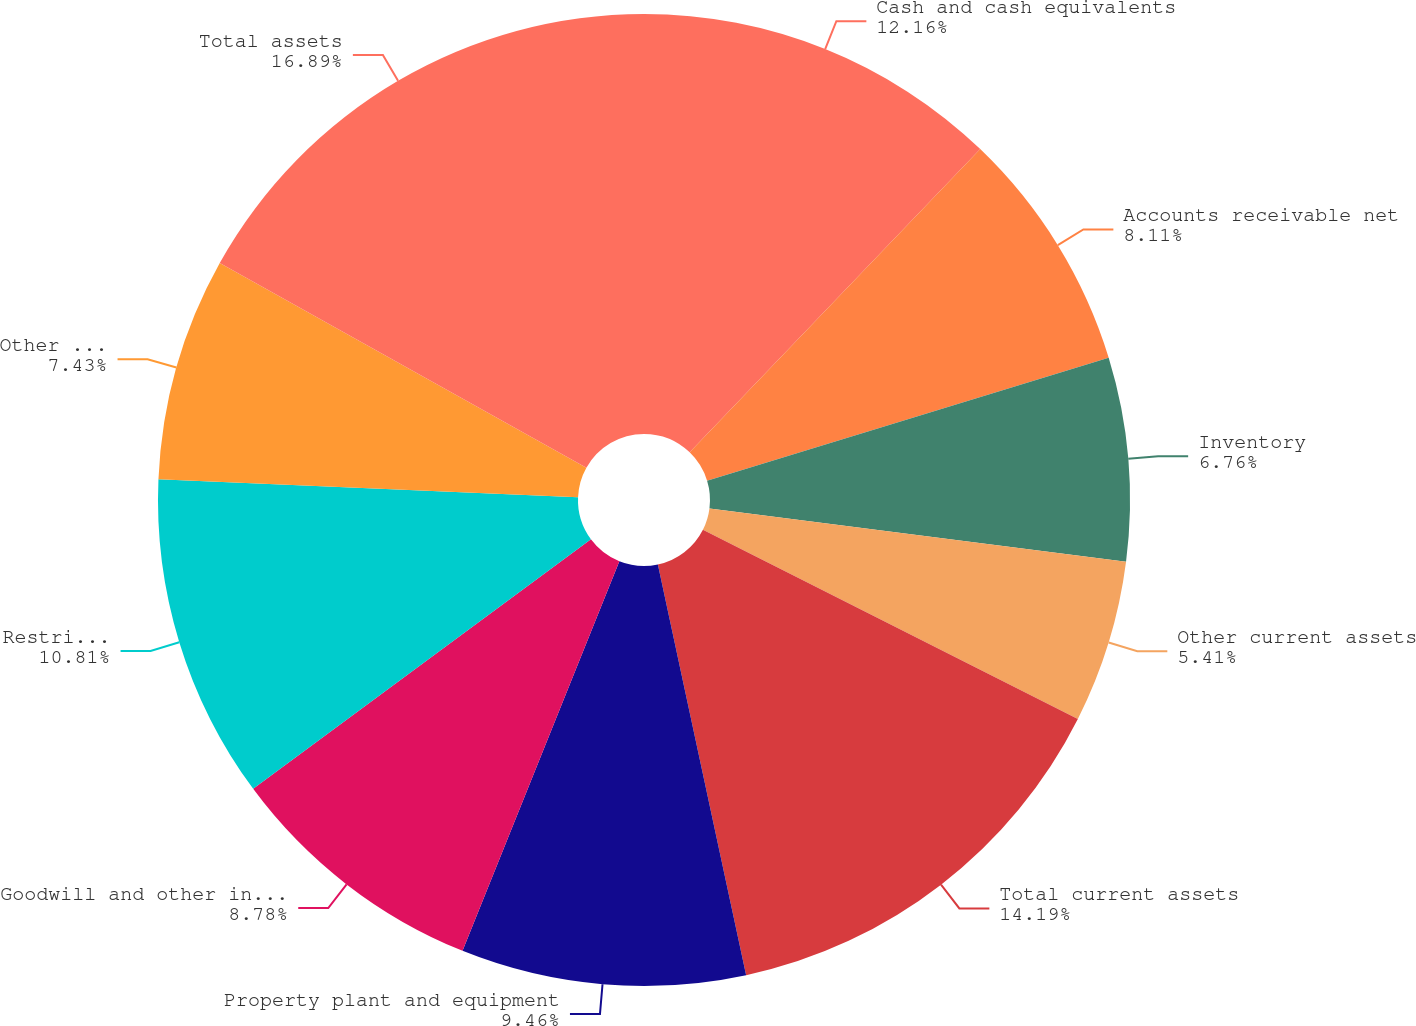Convert chart. <chart><loc_0><loc_0><loc_500><loc_500><pie_chart><fcel>Cash and cash equivalents<fcel>Accounts receivable net<fcel>Inventory<fcel>Other current assets<fcel>Total current assets<fcel>Property plant and equipment<fcel>Goodwill and other intangible<fcel>Restricted cash and cash<fcel>Other assets<fcel>Total assets<nl><fcel>12.16%<fcel>8.11%<fcel>6.76%<fcel>5.41%<fcel>14.19%<fcel>9.46%<fcel>8.78%<fcel>10.81%<fcel>7.43%<fcel>16.89%<nl></chart> 